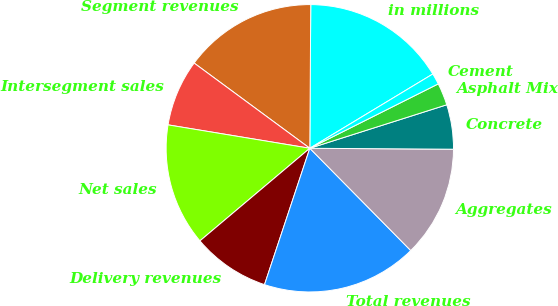Convert chart to OTSL. <chart><loc_0><loc_0><loc_500><loc_500><pie_chart><fcel>in millions<fcel>Segment revenues<fcel>Intersegment sales<fcel>Net sales<fcel>Delivery revenues<fcel>Total revenues<fcel>Aggregates<fcel>Concrete<fcel>Asphalt Mix<fcel>Cement<nl><fcel>16.25%<fcel>15.0%<fcel>7.5%<fcel>13.75%<fcel>8.75%<fcel>17.5%<fcel>12.5%<fcel>5.0%<fcel>2.5%<fcel>1.25%<nl></chart> 